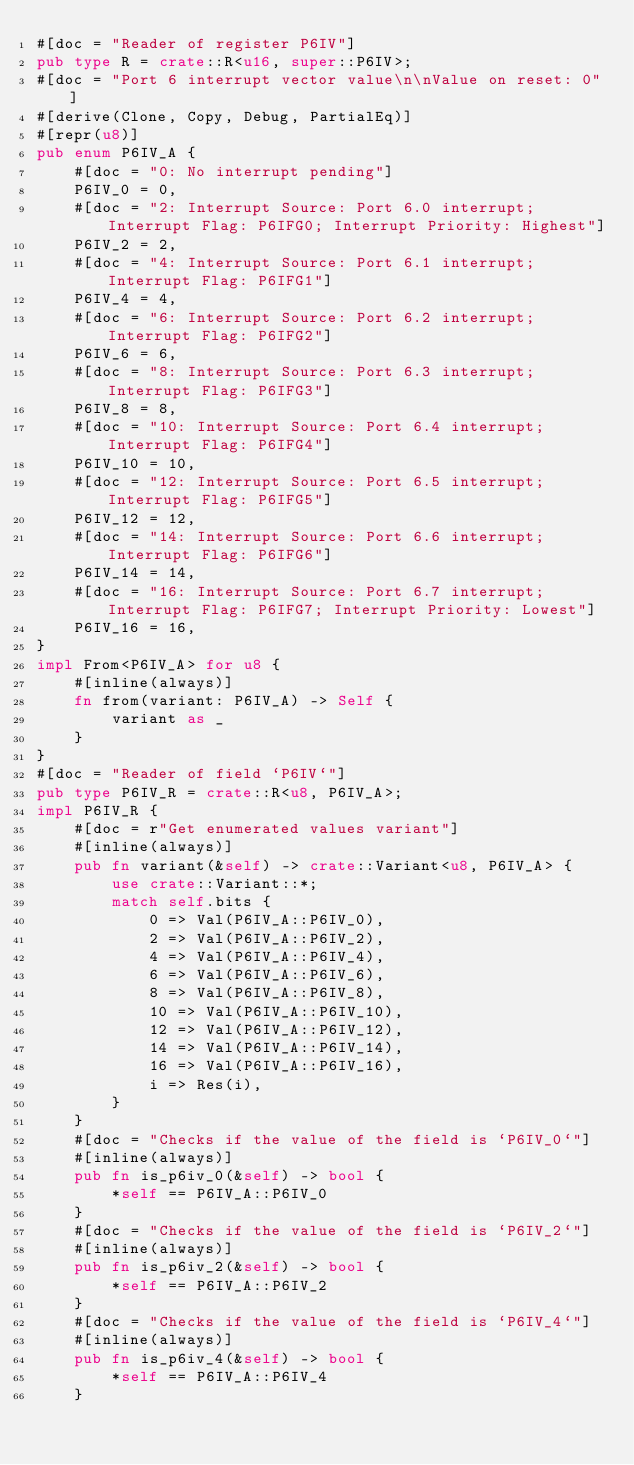Convert code to text. <code><loc_0><loc_0><loc_500><loc_500><_Rust_>#[doc = "Reader of register P6IV"]
pub type R = crate::R<u16, super::P6IV>;
#[doc = "Port 6 interrupt vector value\n\nValue on reset: 0"]
#[derive(Clone, Copy, Debug, PartialEq)]
#[repr(u8)]
pub enum P6IV_A {
    #[doc = "0: No interrupt pending"]
    P6IV_0 = 0,
    #[doc = "2: Interrupt Source: Port 6.0 interrupt; Interrupt Flag: P6IFG0; Interrupt Priority: Highest"]
    P6IV_2 = 2,
    #[doc = "4: Interrupt Source: Port 6.1 interrupt; Interrupt Flag: P6IFG1"]
    P6IV_4 = 4,
    #[doc = "6: Interrupt Source: Port 6.2 interrupt; Interrupt Flag: P6IFG2"]
    P6IV_6 = 6,
    #[doc = "8: Interrupt Source: Port 6.3 interrupt; Interrupt Flag: P6IFG3"]
    P6IV_8 = 8,
    #[doc = "10: Interrupt Source: Port 6.4 interrupt; Interrupt Flag: P6IFG4"]
    P6IV_10 = 10,
    #[doc = "12: Interrupt Source: Port 6.5 interrupt; Interrupt Flag: P6IFG5"]
    P6IV_12 = 12,
    #[doc = "14: Interrupt Source: Port 6.6 interrupt; Interrupt Flag: P6IFG6"]
    P6IV_14 = 14,
    #[doc = "16: Interrupt Source: Port 6.7 interrupt; Interrupt Flag: P6IFG7; Interrupt Priority: Lowest"]
    P6IV_16 = 16,
}
impl From<P6IV_A> for u8 {
    #[inline(always)]
    fn from(variant: P6IV_A) -> Self {
        variant as _
    }
}
#[doc = "Reader of field `P6IV`"]
pub type P6IV_R = crate::R<u8, P6IV_A>;
impl P6IV_R {
    #[doc = r"Get enumerated values variant"]
    #[inline(always)]
    pub fn variant(&self) -> crate::Variant<u8, P6IV_A> {
        use crate::Variant::*;
        match self.bits {
            0 => Val(P6IV_A::P6IV_0),
            2 => Val(P6IV_A::P6IV_2),
            4 => Val(P6IV_A::P6IV_4),
            6 => Val(P6IV_A::P6IV_6),
            8 => Val(P6IV_A::P6IV_8),
            10 => Val(P6IV_A::P6IV_10),
            12 => Val(P6IV_A::P6IV_12),
            14 => Val(P6IV_A::P6IV_14),
            16 => Val(P6IV_A::P6IV_16),
            i => Res(i),
        }
    }
    #[doc = "Checks if the value of the field is `P6IV_0`"]
    #[inline(always)]
    pub fn is_p6iv_0(&self) -> bool {
        *self == P6IV_A::P6IV_0
    }
    #[doc = "Checks if the value of the field is `P6IV_2`"]
    #[inline(always)]
    pub fn is_p6iv_2(&self) -> bool {
        *self == P6IV_A::P6IV_2
    }
    #[doc = "Checks if the value of the field is `P6IV_4`"]
    #[inline(always)]
    pub fn is_p6iv_4(&self) -> bool {
        *self == P6IV_A::P6IV_4
    }</code> 